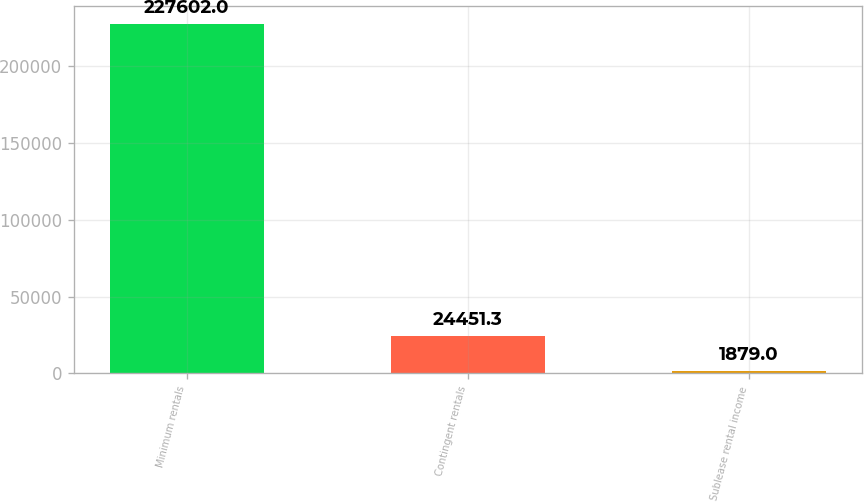Convert chart. <chart><loc_0><loc_0><loc_500><loc_500><bar_chart><fcel>Minimum rentals<fcel>Contingent rentals<fcel>Sublease rental income<nl><fcel>227602<fcel>24451.3<fcel>1879<nl></chart> 